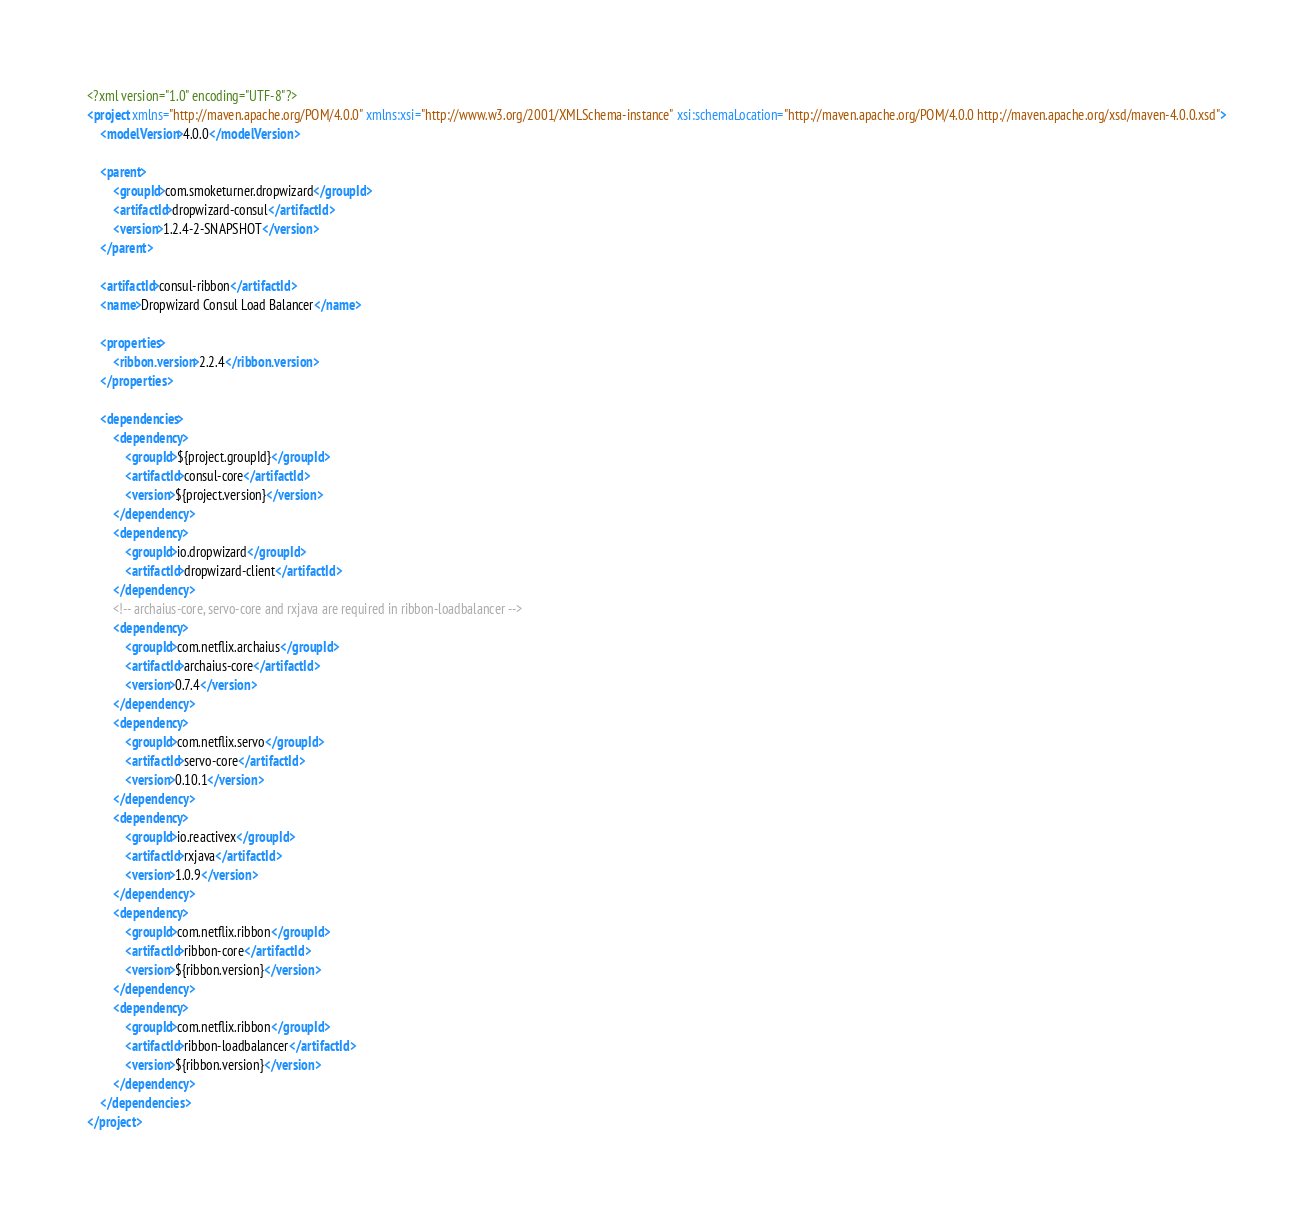<code> <loc_0><loc_0><loc_500><loc_500><_XML_><?xml version="1.0" encoding="UTF-8"?>
<project xmlns="http://maven.apache.org/POM/4.0.0" xmlns:xsi="http://www.w3.org/2001/XMLSchema-instance" xsi:schemaLocation="http://maven.apache.org/POM/4.0.0 http://maven.apache.org/xsd/maven-4.0.0.xsd">
    <modelVersion>4.0.0</modelVersion>

    <parent>
        <groupId>com.smoketurner.dropwizard</groupId>
        <artifactId>dropwizard-consul</artifactId>
        <version>1.2.4-2-SNAPSHOT</version>
    </parent>

    <artifactId>consul-ribbon</artifactId>
    <name>Dropwizard Consul Load Balancer</name>

    <properties>
        <ribbon.version>2.2.4</ribbon.version>
    </properties>

    <dependencies>
        <dependency>
            <groupId>${project.groupId}</groupId>
            <artifactId>consul-core</artifactId>
            <version>${project.version}</version>
        </dependency>
        <dependency>
            <groupId>io.dropwizard</groupId>
            <artifactId>dropwizard-client</artifactId>
        </dependency>
        <!-- archaius-core, servo-core and rxjava are required in ribbon-loadbalancer -->
        <dependency>
            <groupId>com.netflix.archaius</groupId>
            <artifactId>archaius-core</artifactId>
            <version>0.7.4</version>
        </dependency>
        <dependency>
            <groupId>com.netflix.servo</groupId>
            <artifactId>servo-core</artifactId>
            <version>0.10.1</version>
        </dependency>
        <dependency>
            <groupId>io.reactivex</groupId>
            <artifactId>rxjava</artifactId>
            <version>1.0.9</version>
        </dependency>
        <dependency>
            <groupId>com.netflix.ribbon</groupId>
            <artifactId>ribbon-core</artifactId>
            <version>${ribbon.version}</version>
        </dependency>
        <dependency>
            <groupId>com.netflix.ribbon</groupId>
            <artifactId>ribbon-loadbalancer</artifactId>
            <version>${ribbon.version}</version>
        </dependency>
    </dependencies>
</project>
</code> 